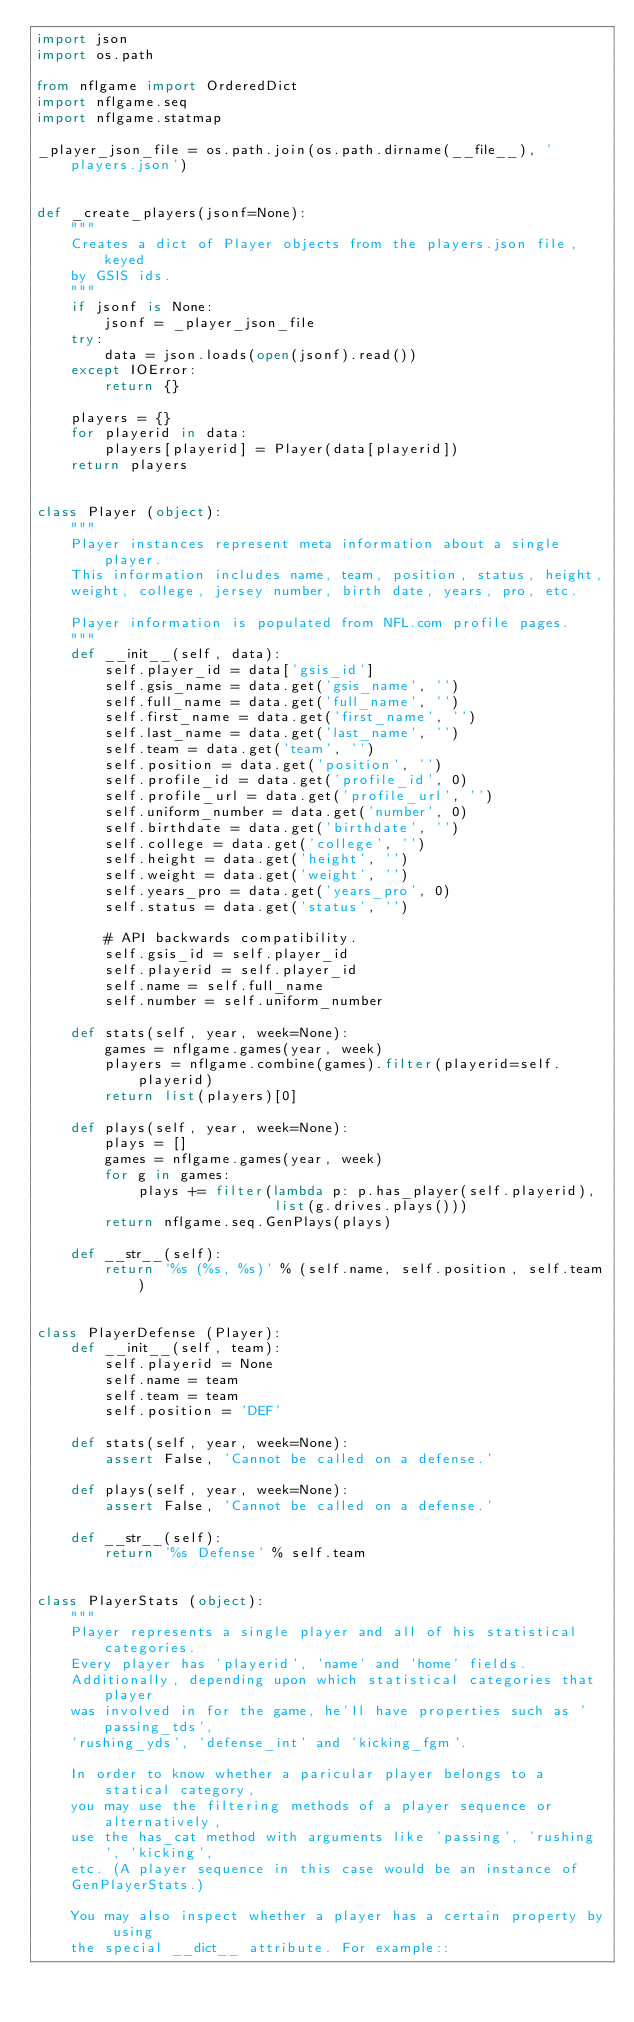Convert code to text. <code><loc_0><loc_0><loc_500><loc_500><_Python_>import json
import os.path

from nflgame import OrderedDict
import nflgame.seq
import nflgame.statmap

_player_json_file = os.path.join(os.path.dirname(__file__), 'players.json')


def _create_players(jsonf=None):
    """
    Creates a dict of Player objects from the players.json file, keyed
    by GSIS ids.
    """
    if jsonf is None:
        jsonf = _player_json_file
    try:
        data = json.loads(open(jsonf).read())
    except IOError:
        return {}

    players = {}
    for playerid in data:
        players[playerid] = Player(data[playerid])
    return players


class Player (object):
    """
    Player instances represent meta information about a single player.
    This information includes name, team, position, status, height,
    weight, college, jersey number, birth date, years, pro, etc.

    Player information is populated from NFL.com profile pages.
    """
    def __init__(self, data):
        self.player_id = data['gsis_id']
        self.gsis_name = data.get('gsis_name', '')
        self.full_name = data.get('full_name', '')
        self.first_name = data.get('first_name', '')
        self.last_name = data.get('last_name', '')
        self.team = data.get('team', '')
        self.position = data.get('position', '')
        self.profile_id = data.get('profile_id', 0)
        self.profile_url = data.get('profile_url', '')
        self.uniform_number = data.get('number', 0)
        self.birthdate = data.get('birthdate', '')
        self.college = data.get('college', '')
        self.height = data.get('height', '')
        self.weight = data.get('weight', '')
        self.years_pro = data.get('years_pro', 0)
        self.status = data.get('status', '')

        # API backwards compatibility.
        self.gsis_id = self.player_id
        self.playerid = self.player_id
        self.name = self.full_name
        self.number = self.uniform_number

    def stats(self, year, week=None):
        games = nflgame.games(year, week)
        players = nflgame.combine(games).filter(playerid=self.playerid)
        return list(players)[0]

    def plays(self, year, week=None):
        plays = []
        games = nflgame.games(year, week)
        for g in games:
            plays += filter(lambda p: p.has_player(self.playerid),
                            list(g.drives.plays()))
        return nflgame.seq.GenPlays(plays)

    def __str__(self):
        return '%s (%s, %s)' % (self.name, self.position, self.team)


class PlayerDefense (Player):
    def __init__(self, team):
        self.playerid = None
        self.name = team
        self.team = team
        self.position = 'DEF'

    def stats(self, year, week=None):
        assert False, 'Cannot be called on a defense.'

    def plays(self, year, week=None):
        assert False, 'Cannot be called on a defense.'

    def __str__(self):
        return '%s Defense' % self.team


class PlayerStats (object):
    """
    Player represents a single player and all of his statistical categories.
    Every player has 'playerid', 'name' and 'home' fields.
    Additionally, depending upon which statistical categories that player
    was involved in for the game, he'll have properties such as 'passing_tds',
    'rushing_yds', 'defense_int' and 'kicking_fgm'.

    In order to know whether a paricular player belongs to a statical category,
    you may use the filtering methods of a player sequence or alternatively,
    use the has_cat method with arguments like 'passing', 'rushing', 'kicking',
    etc. (A player sequence in this case would be an instance of
    GenPlayerStats.)

    You may also inspect whether a player has a certain property by using
    the special __dict__ attribute. For example::
</code> 